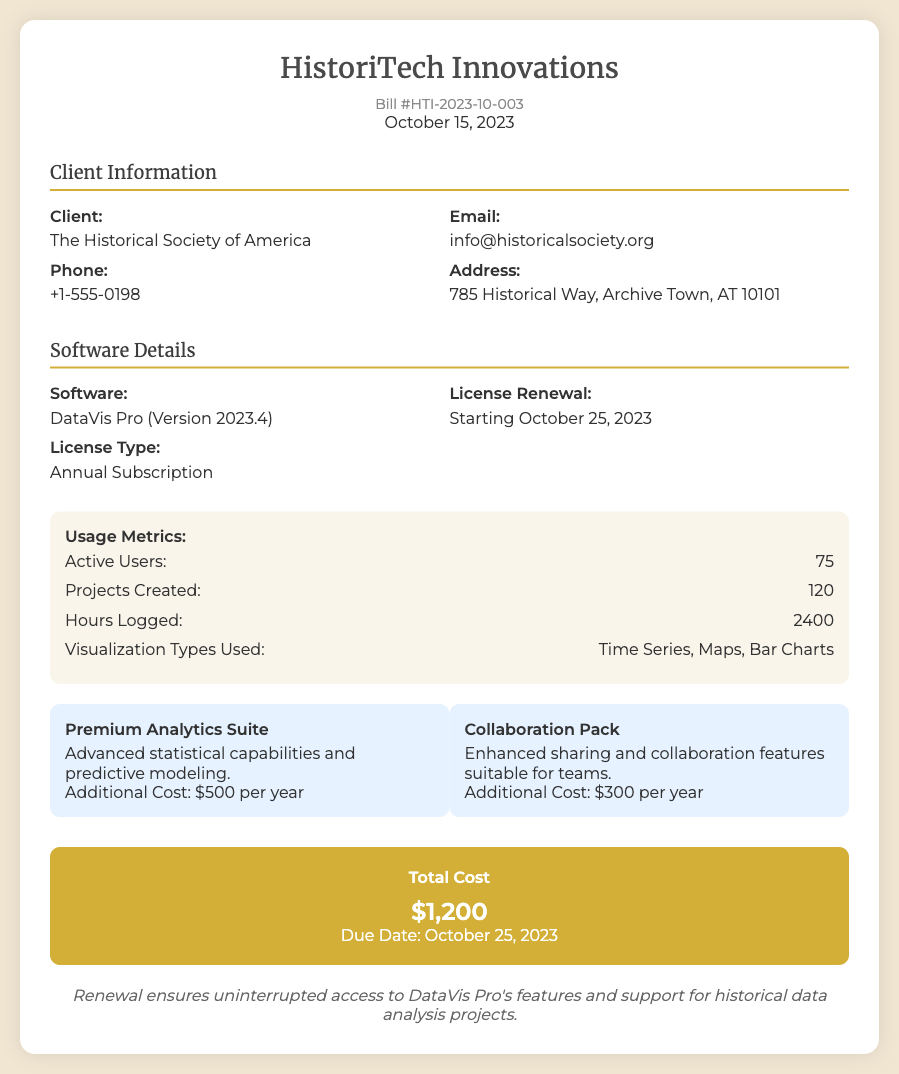What is the bill number? The bill number is listed at the top of the document, specifically as Bill #HTI-2023-10-003.
Answer: Bill #HTI-2023-10-003 What is the total cost? The total cost is mentioned in the cost breakdown section of the document and states $1,200.
Answer: $1,200 Who is the client? The client's name is provided in the client information section as The Historical Society of America.
Answer: The Historical Society of America When is the license renewal due date? The due date for the license renewal is specified in the cost breakdown section as October 25, 2023.
Answer: October 25, 2023 How many active users are noted? The number of active users is found in the usage metrics section and is 75.
Answer: 75 What is an additional cost for the Premium Analytics Suite? The additional cost for the Premium Analytics Suite is stated in the upgrade options section as $500 per year.
Answer: $500 per year What is the type of license mentioned? The software license type is indicated as Annual Subscription in the software details section.
Answer: Annual Subscription What visualization types are used? The types of visualizations used are listed in the usage metrics section: Time Series, Maps, Bar Charts.
Answer: Time Series, Maps, Bar Charts What is noted about the renewal? The notes at the bottom indicate that the renewal ensures uninterrupted access to features and support.
Answer: Uninterrupted access to features and support 